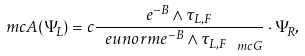Convert formula to latex. <formula><loc_0><loc_0><loc_500><loc_500>\ m c { A } ( \Psi _ { L } ) = c \frac { e ^ { - B } \wedge \tau _ { L , F } } { \ e u n o r m { e ^ { - B } \wedge \tau _ { L , F } } _ { \ m c { G } } } \cdot \Psi _ { R } ,</formula> 